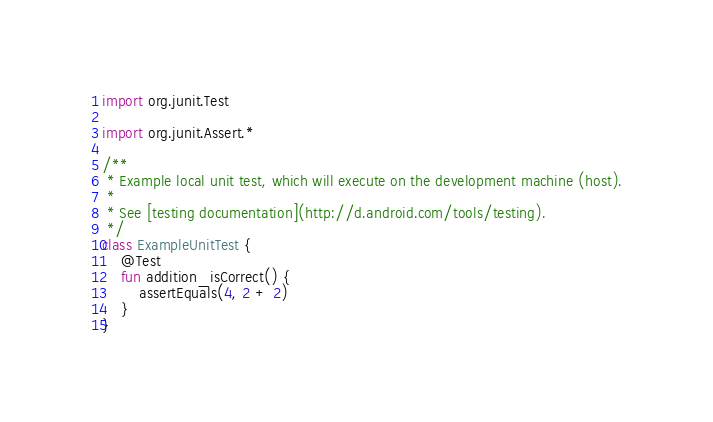<code> <loc_0><loc_0><loc_500><loc_500><_Kotlin_>import org.junit.Test

import org.junit.Assert.*

/**
 * Example local unit test, which will execute on the development machine (host).
 *
 * See [testing documentation](http://d.android.com/tools/testing).
 */
class ExampleUnitTest {
    @Test
    fun addition_isCorrect() {
        assertEquals(4, 2 + 2)
    }
}</code> 